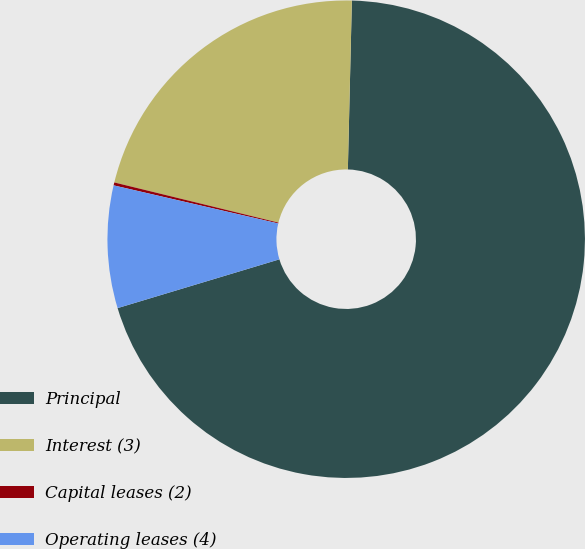<chart> <loc_0><loc_0><loc_500><loc_500><pie_chart><fcel>Principal<fcel>Interest (3)<fcel>Capital leases (2)<fcel>Operating leases (4)<nl><fcel>69.97%<fcel>21.56%<fcel>0.2%<fcel>8.28%<nl></chart> 